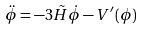Convert formula to latex. <formula><loc_0><loc_0><loc_500><loc_500>\ddot { \phi } = - 3 \tilde { H } \dot { \phi } - V ^ { \prime } ( \phi )</formula> 